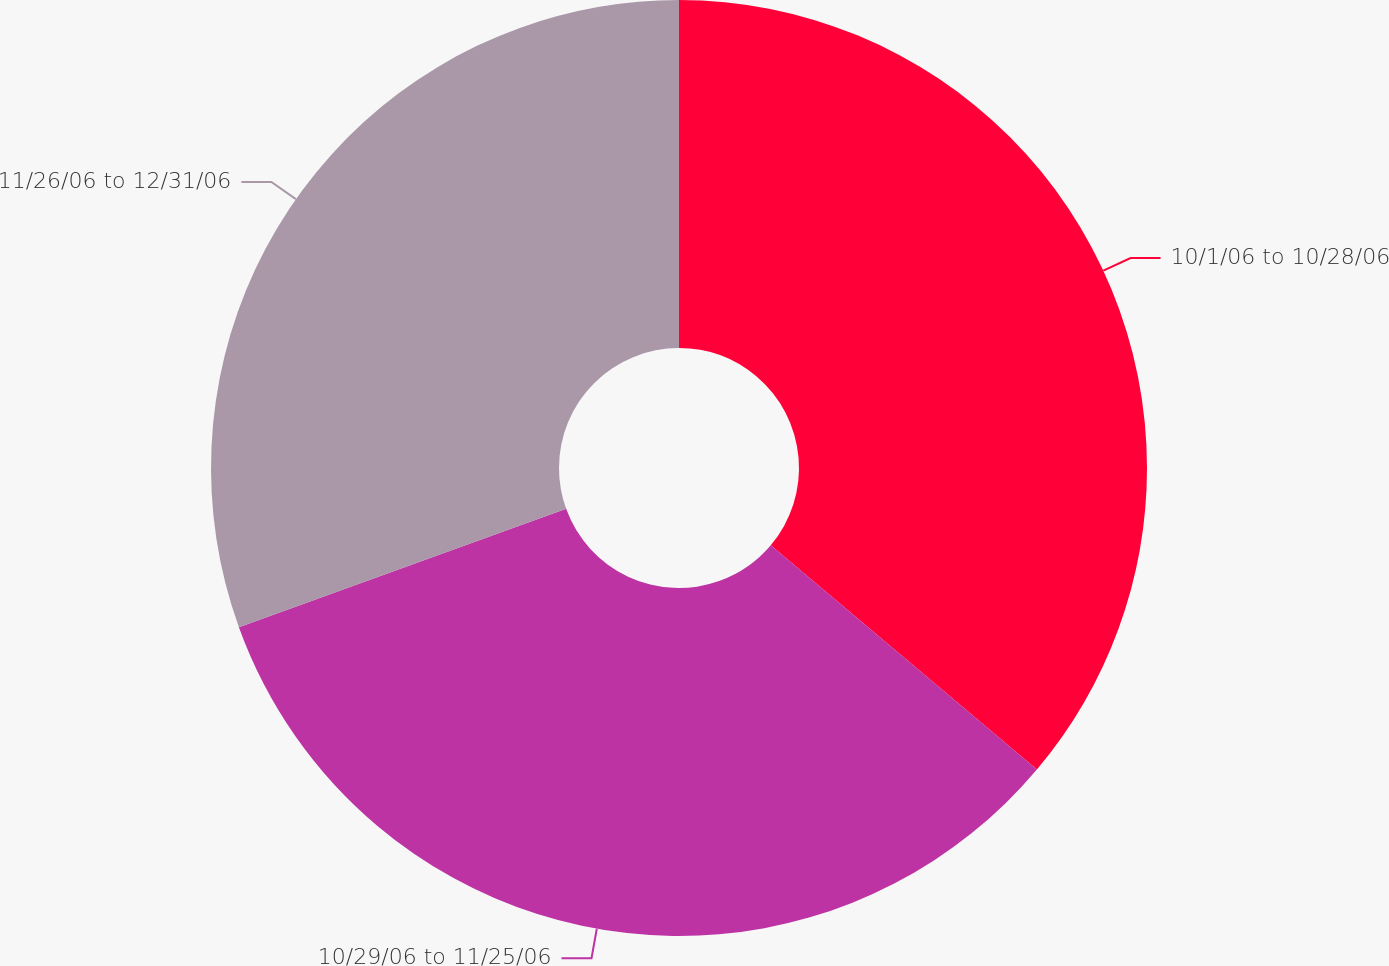<chart> <loc_0><loc_0><loc_500><loc_500><pie_chart><fcel>10/1/06 to 10/28/06<fcel>10/29/06 to 11/25/06<fcel>11/26/06 to 12/31/06<nl><fcel>36.14%<fcel>33.33%<fcel>30.52%<nl></chart> 